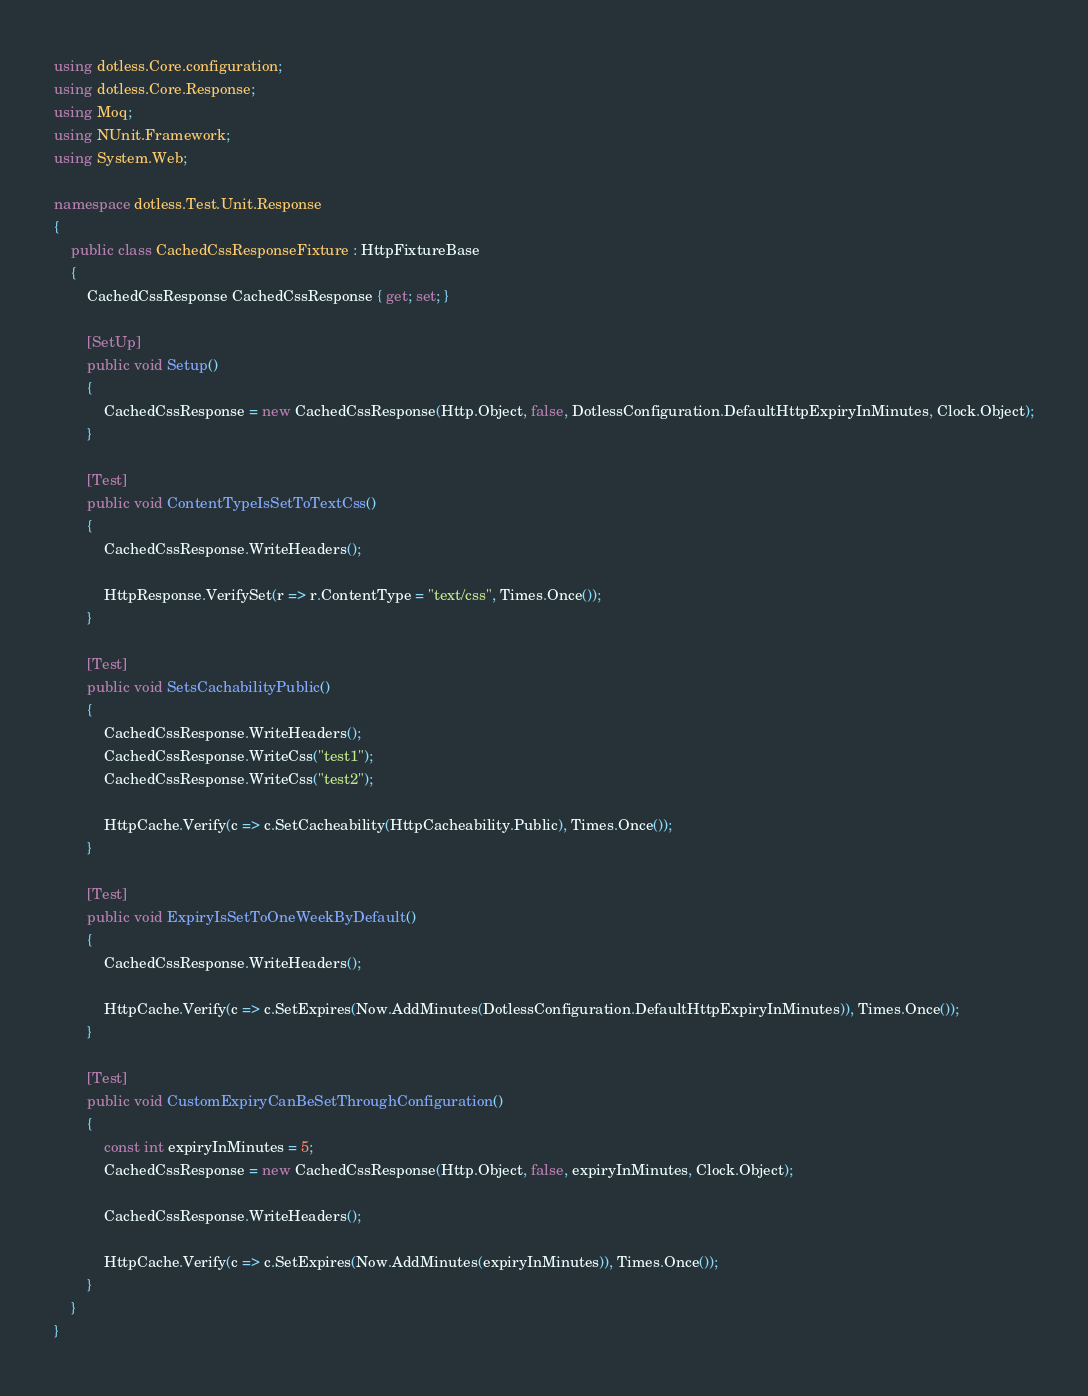<code> <loc_0><loc_0><loc_500><loc_500><_C#_>using dotless.Core.configuration;
using dotless.Core.Response;
using Moq;
using NUnit.Framework;
using System.Web;

namespace dotless.Test.Unit.Response
{
    public class CachedCssResponseFixture : HttpFixtureBase
    {
        CachedCssResponse CachedCssResponse { get; set; }

        [SetUp]
        public void Setup()
        {
            CachedCssResponse = new CachedCssResponse(Http.Object, false, DotlessConfiguration.DefaultHttpExpiryInMinutes, Clock.Object);
        }

        [Test]
        public void ContentTypeIsSetToTextCss()
        {
            CachedCssResponse.WriteHeaders();

            HttpResponse.VerifySet(r => r.ContentType = "text/css", Times.Once());
        }

        [Test]
        public void SetsCachabilityPublic()
        {
            CachedCssResponse.WriteHeaders();
            CachedCssResponse.WriteCss("test1");
            CachedCssResponse.WriteCss("test2");

            HttpCache.Verify(c => c.SetCacheability(HttpCacheability.Public), Times.Once());
        }

        [Test]
        public void ExpiryIsSetToOneWeekByDefault()
        {
            CachedCssResponse.WriteHeaders();

            HttpCache.Verify(c => c.SetExpires(Now.AddMinutes(DotlessConfiguration.DefaultHttpExpiryInMinutes)), Times.Once());
        }

        [Test]
        public void CustomExpiryCanBeSetThroughConfiguration()
        {
            const int expiryInMinutes = 5;
            CachedCssResponse = new CachedCssResponse(Http.Object, false, expiryInMinutes, Clock.Object);

            CachedCssResponse.WriteHeaders();

            HttpCache.Verify(c => c.SetExpires(Now.AddMinutes(expiryInMinutes)), Times.Once());
        }
    }
}</code> 